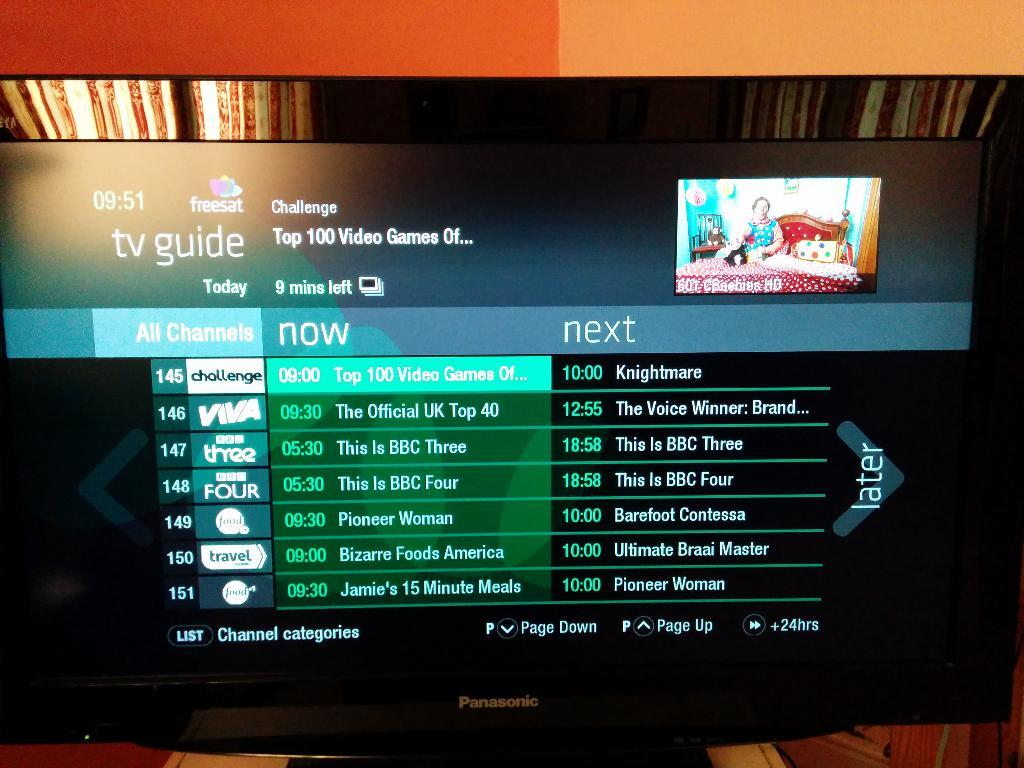Provide a one-sentence caption for the provided image. The TV guide channel on a television shows the shows coming up on channel 145 through channel 151. 